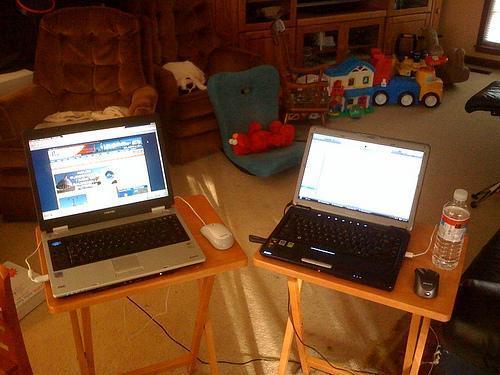How many laptops are there?
Give a very brief answer. 2. How many laptops are in the photo?
Give a very brief answer. 2. How many laptops are in the picture?
Give a very brief answer. 2. 